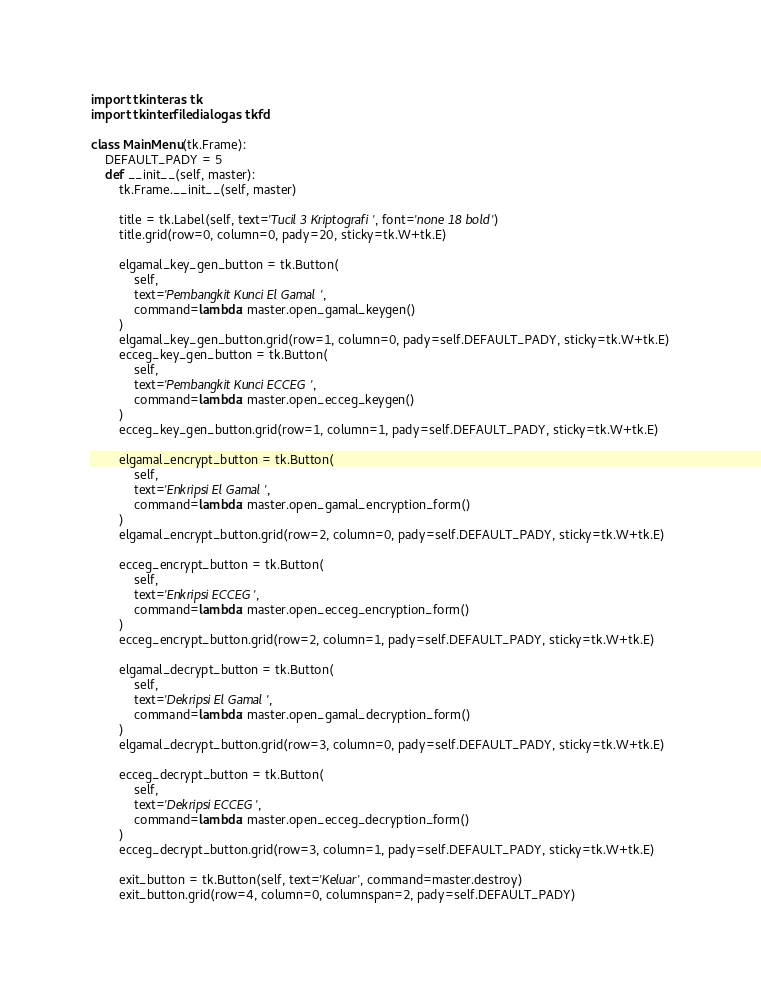<code> <loc_0><loc_0><loc_500><loc_500><_Python_>import tkinter as tk
import tkinter.filedialog as tkfd

class MainMenu(tk.Frame):
    DEFAULT_PADY = 5
    def __init__(self, master):
        tk.Frame.__init__(self, master)

        title = tk.Label(self, text='Tucil 3 Kriptografi', font='none 18 bold')
        title.grid(row=0, column=0, pady=20, sticky=tk.W+tk.E)

        elgamal_key_gen_button = tk.Button(
            self,
            text='Pembangkit Kunci El Gamal',
            command=lambda: master.open_gamal_keygen()
        )
        elgamal_key_gen_button.grid(row=1, column=0, pady=self.DEFAULT_PADY, sticky=tk.W+tk.E)
        ecceg_key_gen_button = tk.Button(
            self,
            text='Pembangkit Kunci ECCEG',
            command=lambda: master.open_ecceg_keygen()
        )
        ecceg_key_gen_button.grid(row=1, column=1, pady=self.DEFAULT_PADY, sticky=tk.W+tk.E)

        elgamal_encrypt_button = tk.Button(
            self,
            text='Enkripsi El Gamal',
            command=lambda: master.open_gamal_encryption_form()
        )
        elgamal_encrypt_button.grid(row=2, column=0, pady=self.DEFAULT_PADY, sticky=tk.W+tk.E)

        ecceg_encrypt_button = tk.Button(
            self,
            text='Enkripsi ECCEG',
            command=lambda: master.open_ecceg_encryption_form()
        )
        ecceg_encrypt_button.grid(row=2, column=1, pady=self.DEFAULT_PADY, sticky=tk.W+tk.E)

        elgamal_decrypt_button = tk.Button(
            self,
            text='Dekripsi El Gamal',
            command=lambda: master.open_gamal_decryption_form()
        )
        elgamal_decrypt_button.grid(row=3, column=0, pady=self.DEFAULT_PADY, sticky=tk.W+tk.E)

        ecceg_decrypt_button = tk.Button(
            self,
            text='Dekripsi ECCEG',
            command=lambda: master.open_ecceg_decryption_form()
        )
        ecceg_decrypt_button.grid(row=3, column=1, pady=self.DEFAULT_PADY, sticky=tk.W+tk.E)

        exit_button = tk.Button(self, text='Keluar', command=master.destroy)
        exit_button.grid(row=4, column=0, columnspan=2, pady=self.DEFAULT_PADY)</code> 